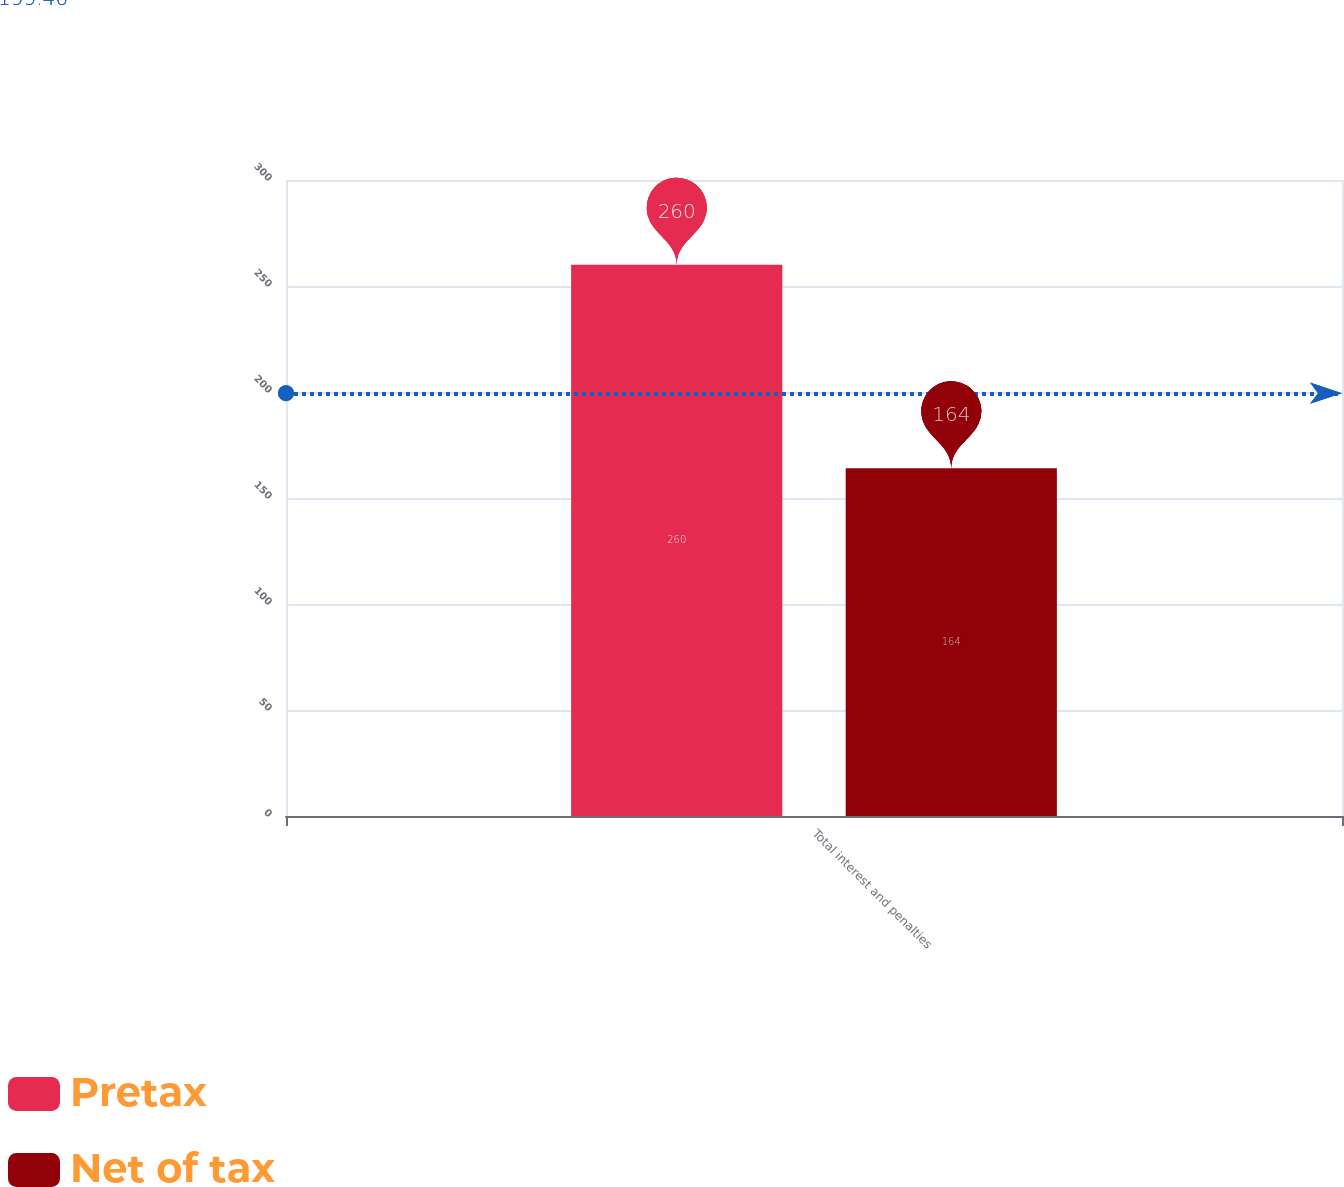Convert chart to OTSL. <chart><loc_0><loc_0><loc_500><loc_500><stacked_bar_chart><ecel><fcel>Total interest and penalties<nl><fcel>Pretax<fcel>260<nl><fcel>Net of tax<fcel>164<nl></chart> 